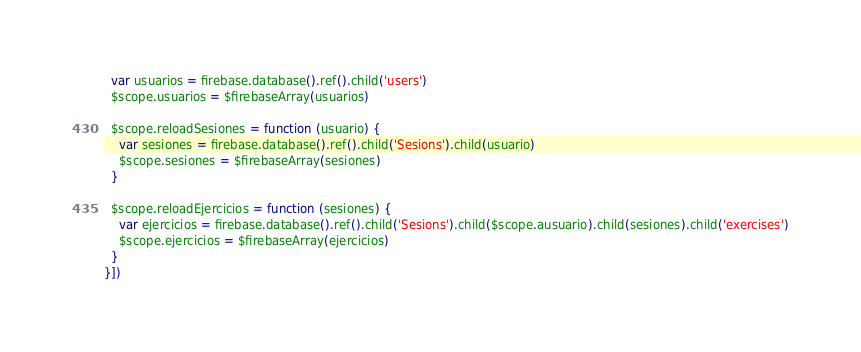Convert code to text. <code><loc_0><loc_0><loc_500><loc_500><_JavaScript_>  var usuarios = firebase.database().ref().child('users')
  $scope.usuarios = $firebaseArray(usuarios)

  $scope.reloadSesiones = function (usuario) {
    var sesiones = firebase.database().ref().child('Sesions').child(usuario)
    $scope.sesiones = $firebaseArray(sesiones)
  }

  $scope.reloadEjercicios = function (sesiones) {
    var ejercicios = firebase.database().ref().child('Sesions').child($scope.ausuario).child(sesiones).child('exercises')
    $scope.ejercicios = $firebaseArray(ejercicios)
  }
}])
</code> 